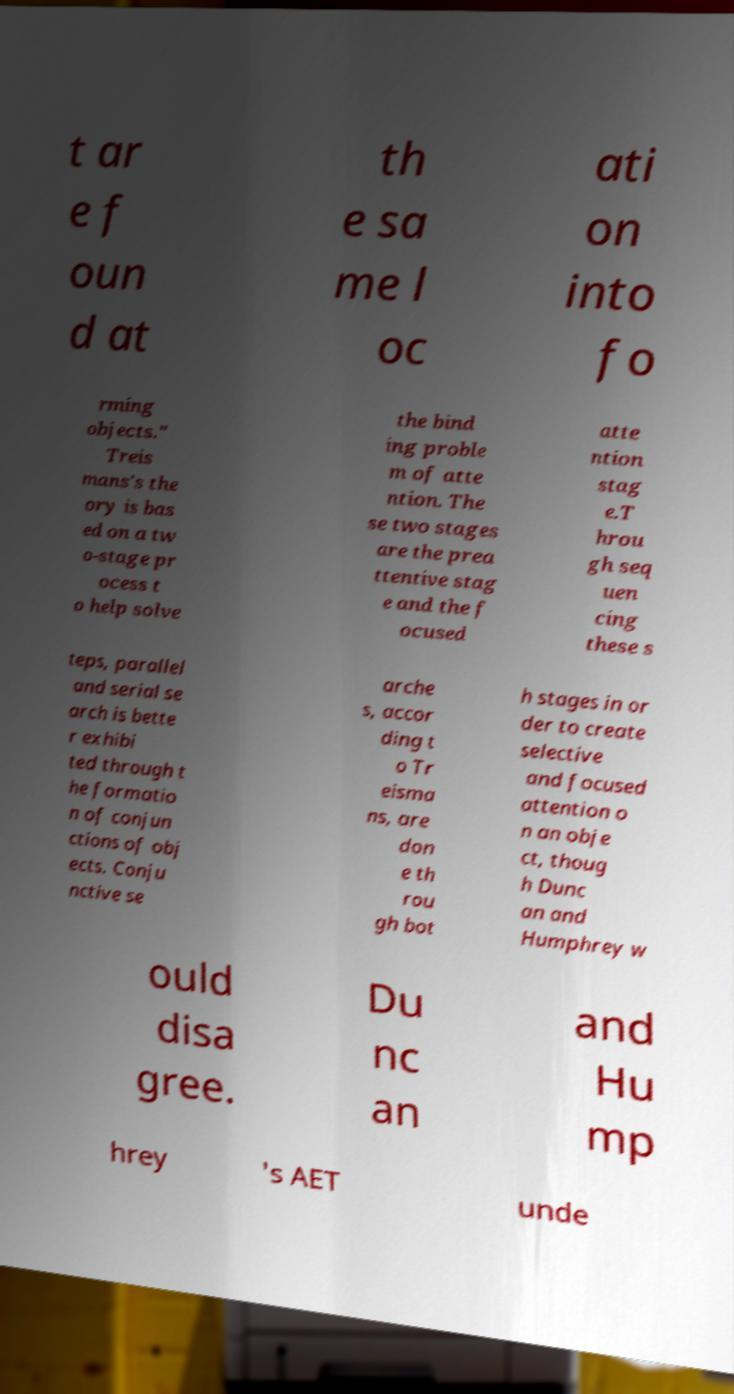Please identify and transcribe the text found in this image. t ar e f oun d at th e sa me l oc ati on into fo rming objects." Treis mans's the ory is bas ed on a tw o-stage pr ocess t o help solve the bind ing proble m of atte ntion. The se two stages are the prea ttentive stag e and the f ocused atte ntion stag e.T hrou gh seq uen cing these s teps, parallel and serial se arch is bette r exhibi ted through t he formatio n of conjun ctions of obj ects. Conju nctive se arche s, accor ding t o Tr eisma ns, are don e th rou gh bot h stages in or der to create selective and focused attention o n an obje ct, thoug h Dunc an and Humphrey w ould disa gree. Du nc an and Hu mp hrey 's AET unde 